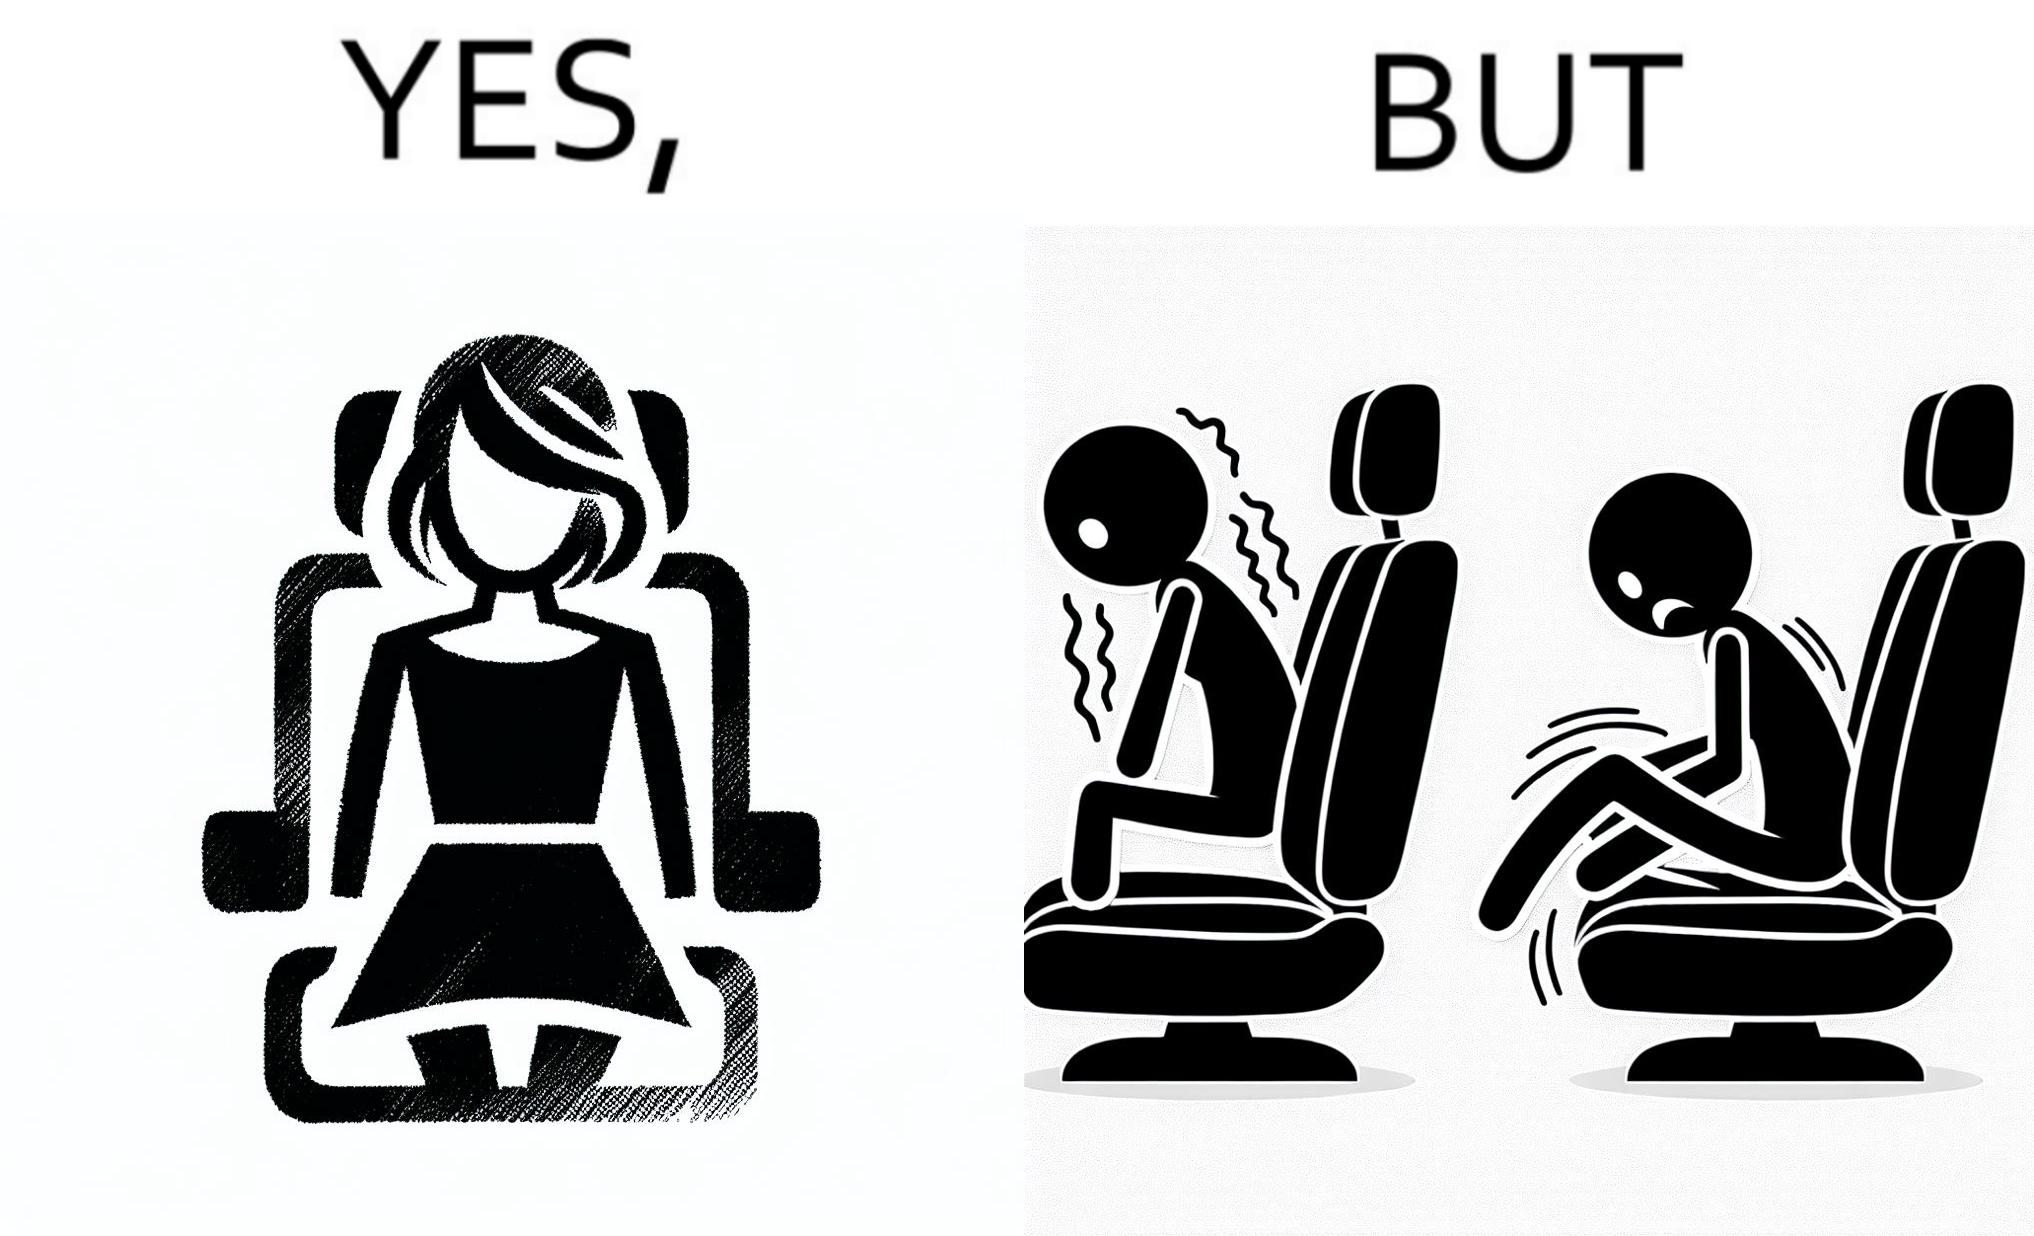Describe what you see in this image. The image is ironic, because the woman is wearing a short dress to look stylish but she had to face inconvenience while travelling in car due to her short dress only. 